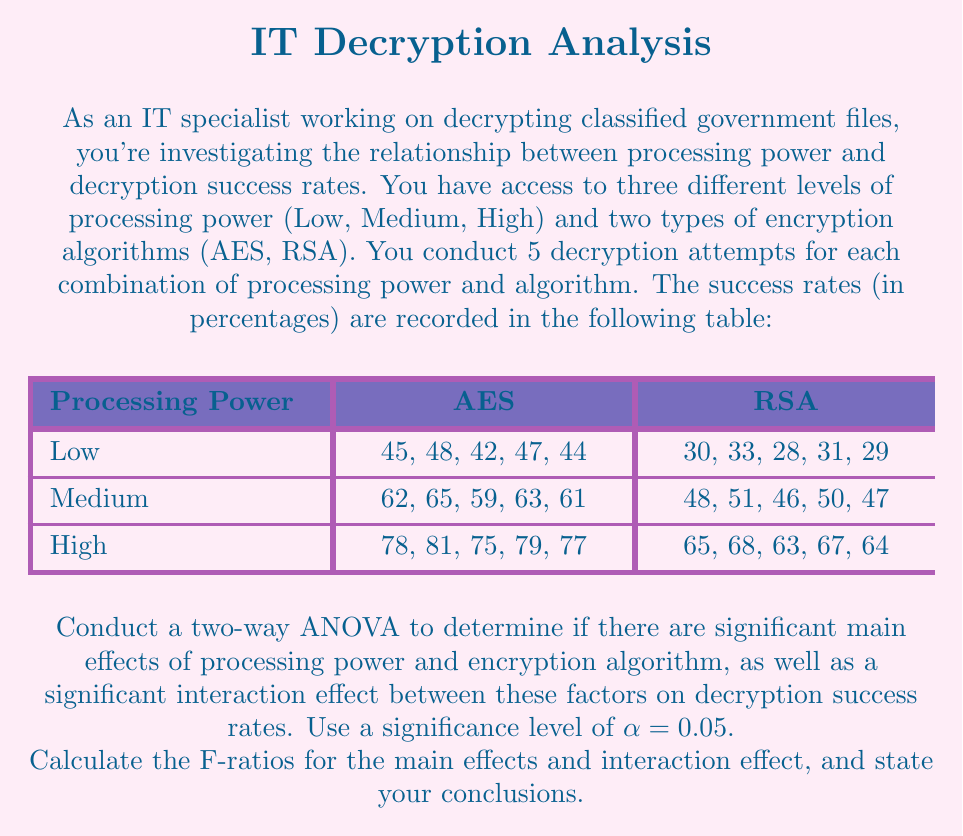Can you answer this question? To conduct a two-way ANOVA, we need to follow these steps:

1. Calculate the sum of squares for each source of variation:
   - Total Sum of Squares (SST)
   - Sum of Squares for Processing Power (SSA)
   - Sum of Squares for Encryption Algorithm (SSB)
   - Sum of Squares for Interaction (SSAB)
   - Sum of Squares for Error (SSE)

2. Calculate the degrees of freedom for each source of variation
3. Calculate the Mean Square for each source of variation
4. Calculate the F-ratios
5. Compare the F-ratios to the critical F-values

Let's go through each step:

Step 1: Calculate Sum of Squares

First, we need to calculate the grand mean:
$$\bar{X} = \frac{\text{Sum of all observations}}{\text{Total number of observations}} = 54.9$$

SST = $\sum_{i=1}^{3}\sum_{j=1}^{2}\sum_{k=1}^{5} (X_{ijk} - \bar{X})^2 = 11,030.3$

SSA = $5 \cdot 2 \cdot \sum_{i=1}^{3} (\bar{X}_{i..} - \bar{X})^2 = 9,720$

SSB = $5 \cdot 3 \cdot \sum_{j=1}^{2} (\bar{X}_{.j.} - \bar{X})^2 = 1,080$

SSAB = $5 \cdot \sum_{i=1}^{3}\sum_{j=1}^{2} (\bar{X}_{ij.} - \bar{X}_{i..} - \bar{X}_{.j.} + \bar{X})^2 = 30$

SSE = SST - SSA - SSB - SSAB = 200.3

Step 2: Degrees of Freedom

df(A) = 3 - 1 = 2 (Processing Power)
df(B) = 2 - 1 = 1 (Encryption Algorithm)
df(AB) = df(A) * df(B) = 2
df(E) = 3 * 2 * (5 - 1) = 24
df(T) = (3 * 2 * 5) - 1 = 29

Step 3: Mean Squares

MSA = SSA / df(A) = 9,720 / 2 = 4,860
MSB = SSB / df(B) = 1,080 / 1 = 1,080
MSAB = SSAB / df(AB) = 30 / 2 = 15
MSE = SSE / df(E) = 200.3 / 24 = 8.3458

Step 4: F-ratios

F(A) = MSA / MSE = 4,860 / 8.3458 = 582.32
F(B) = MSB / MSE = 1,080 / 8.3458 = 129.41
F(AB) = MSAB / MSE = 15 / 8.3458 = 1.80

Step 5: Compare to Critical F-values

At $\alpha = 0.05$:
F-critical(A) = F(2, 24) = 3.40
F-critical(B) = F(1, 24) = 4.26
F-critical(AB) = F(2, 24) = 3.40

Conclusions:
1. For Processing Power: F(A) = 582.32 > F-critical(A) = 3.40, so we reject the null hypothesis. There is a significant main effect of processing power on decryption success rates.
2. For Encryption Algorithm: F(B) = 129.41 > F-critical(B) = 4.26, so we reject the null hypothesis. There is a significant main effect of encryption algorithm on decryption success rates.
3. For Interaction: F(AB) = 1.80 < F-critical(AB) = 3.40, so we fail to reject the null hypothesis. There is no significant interaction effect between processing power and encryption algorithm on decryption success rates.
Answer: F-ratios:
Processing Power: F(A) = 582.32
Encryption Algorithm: F(B) = 129.41
Interaction: F(AB) = 1.80

Conclusions:
1. Significant main effect of processing power on decryption success rates (p < 0.05)
2. Significant main effect of encryption algorithm on decryption success rates (p < 0.05)
3. No significant interaction effect between processing power and encryption algorithm on decryption success rates (p > 0.05) 